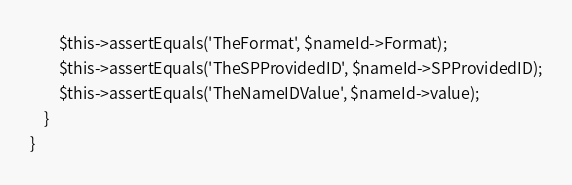Convert code to text. <code><loc_0><loc_0><loc_500><loc_500><_PHP_>        $this->assertEquals('TheFormat', $nameId->Format);
        $this->assertEquals('TheSPProvidedID', $nameId->SPProvidedID);
        $this->assertEquals('TheNameIDValue', $nameId->value);
    }
}




</code> 